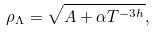Convert formula to latex. <formula><loc_0><loc_0><loc_500><loc_500>\rho _ { \Lambda } = \sqrt { A + \alpha T ^ { - 3 h } } ,</formula> 